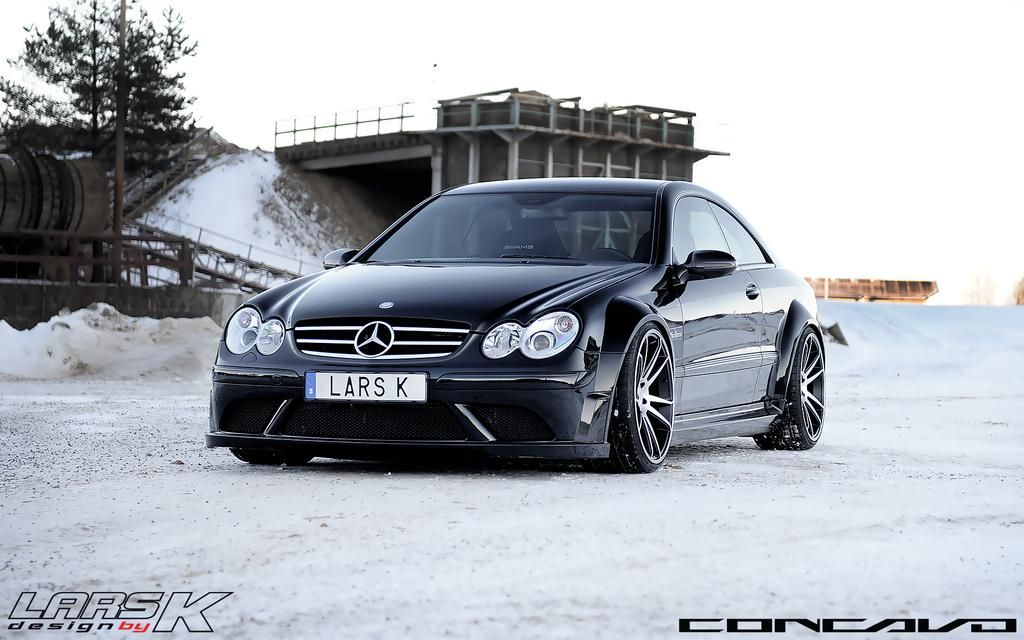What is on the road in the image? There is a car on the road in the image. What can be seen in the background of the image? There is a tree, a pole, and a wall in the background of the image. What is the color of the wall in the background? The wall in the background is white in color. What type of cord is hanging from the tree in the image? There is no cord hanging from the tree in the image. 